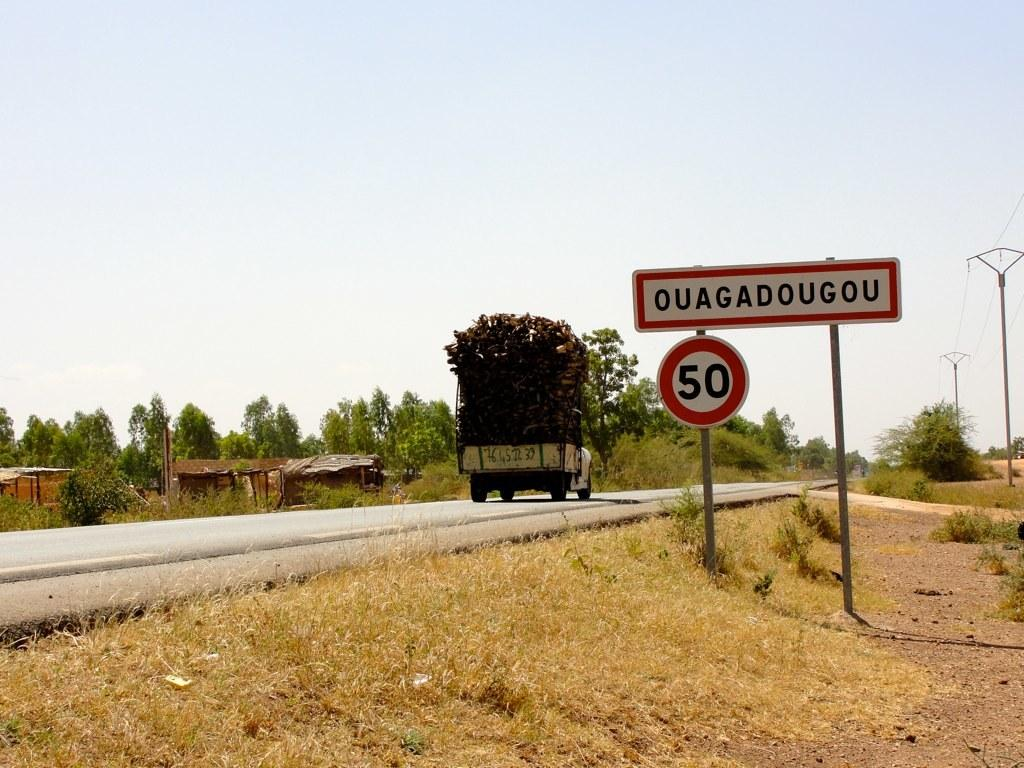Provide a one-sentence caption for the provided image. a street with a sign for Ouagadougou 50. 